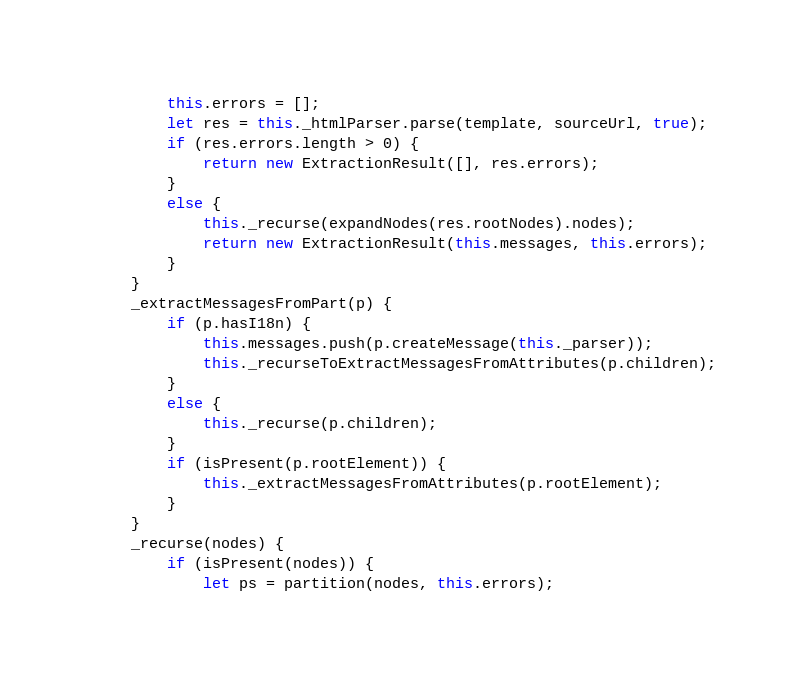Convert code to text. <code><loc_0><loc_0><loc_500><loc_500><_JavaScript_>        this.errors = [];
        let res = this._htmlParser.parse(template, sourceUrl, true);
        if (res.errors.length > 0) {
            return new ExtractionResult([], res.errors);
        }
        else {
            this._recurse(expandNodes(res.rootNodes).nodes);
            return new ExtractionResult(this.messages, this.errors);
        }
    }
    _extractMessagesFromPart(p) {
        if (p.hasI18n) {
            this.messages.push(p.createMessage(this._parser));
            this._recurseToExtractMessagesFromAttributes(p.children);
        }
        else {
            this._recurse(p.children);
        }
        if (isPresent(p.rootElement)) {
            this._extractMessagesFromAttributes(p.rootElement);
        }
    }
    _recurse(nodes) {
        if (isPresent(nodes)) {
            let ps = partition(nodes, this.errors);</code> 